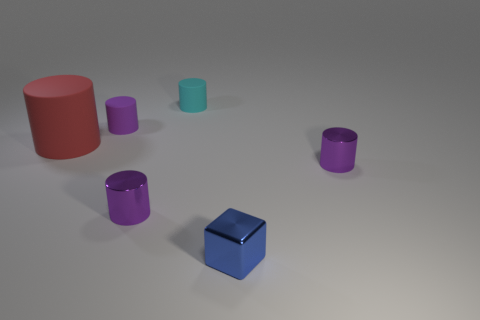What materials do the various objects in the image appear to be made from? The objects seem to have different materials. The red and blue ones have a matte appearance suggesting they might be made of plastic, while the metallic sheen on the purple objects hints that they could be made of metal. The small teal object has a translucent quality, which might indicate it's made of glass or a similarly transparent material. 